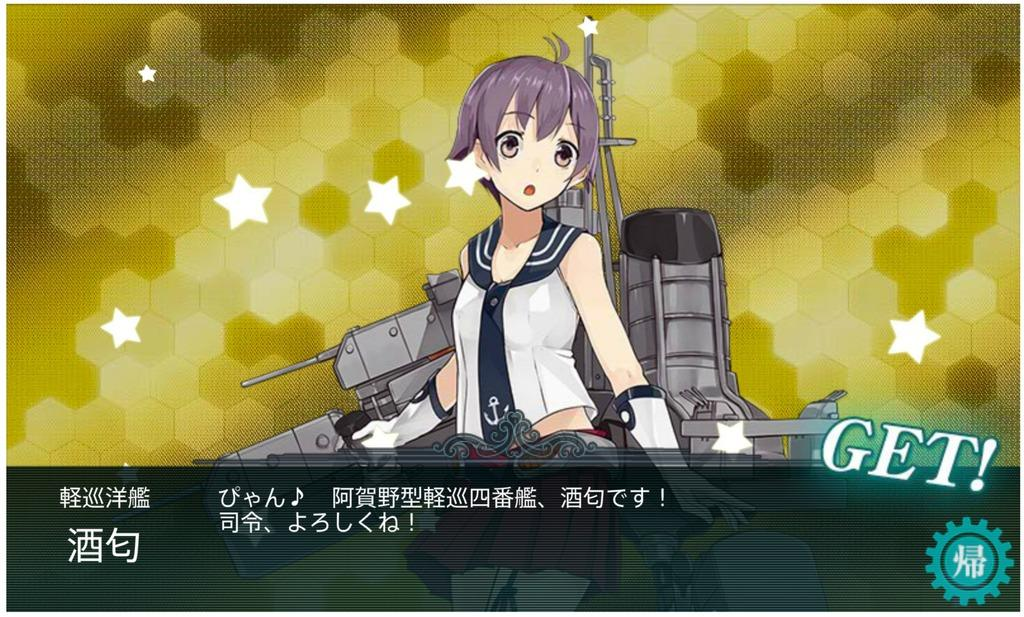What type of image is being described? The image is animated. Can you describe the character in the image? There is a beautiful girl standing in the image. Where can the word "get" be found in the image? The word "get" is present on the right side of the image. How does the goose contribute to the harmony in the image? There is no goose present in the image, so it cannot contribute to the harmony. 